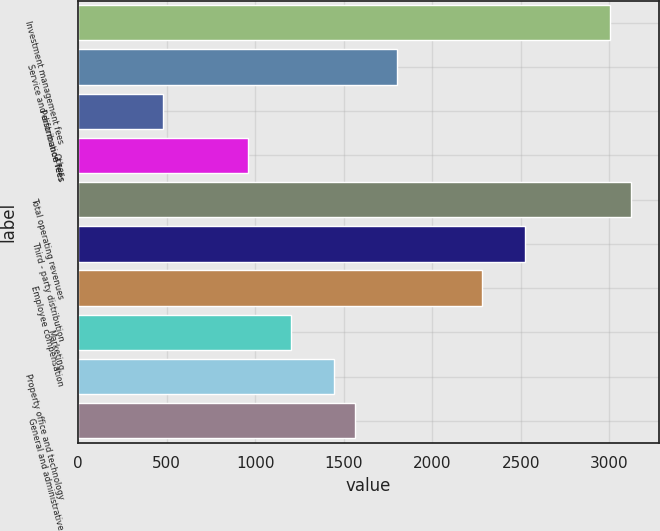<chart> <loc_0><loc_0><loc_500><loc_500><bar_chart><fcel>Investment management fees<fcel>Service and distribution fees<fcel>Performance fees<fcel>Other<fcel>Total operating revenues<fcel>Third - party distribution<fcel>Employee compensation<fcel>Marketing<fcel>Property office and technology<fcel>General and administrative<nl><fcel>3003.53<fcel>1802.23<fcel>480.8<fcel>961.32<fcel>3123.66<fcel>2523.01<fcel>2282.75<fcel>1201.58<fcel>1441.84<fcel>1561.97<nl></chart> 